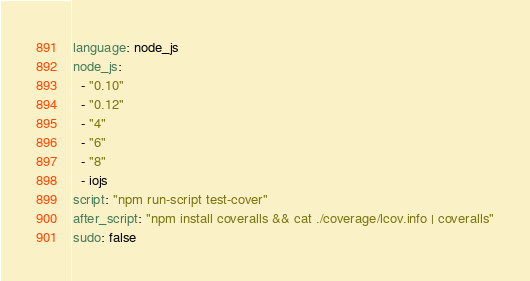Convert code to text. <code><loc_0><loc_0><loc_500><loc_500><_YAML_>language: node_js
node_js:
  - "0.10"
  - "0.12"
  - "4"
  - "6"
  - "8"
  - iojs
script: "npm run-script test-cover"
after_script: "npm install coveralls && cat ./coverage/lcov.info | coveralls"
sudo: false
</code> 